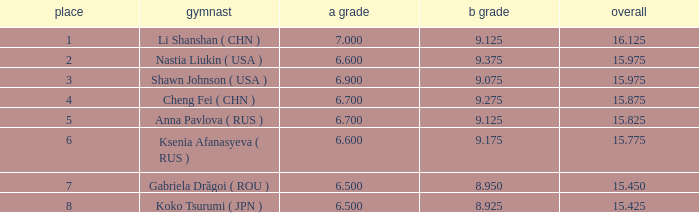What the B Score when the total is 16.125 and the position is less than 7? 9.125. 